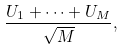Convert formula to latex. <formula><loc_0><loc_0><loc_500><loc_500>\frac { U _ { 1 } + \dots + U _ { M } } { \sqrt { M } } ,</formula> 